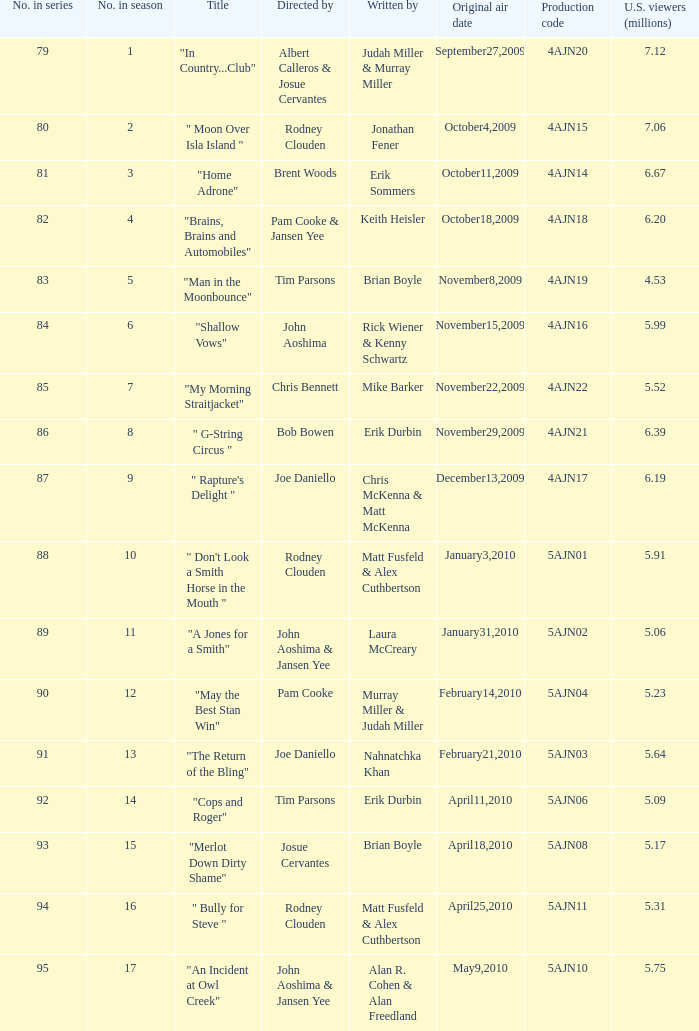Identify the author of number 88. Matt Fusfeld & Alex Cuthbertson. 